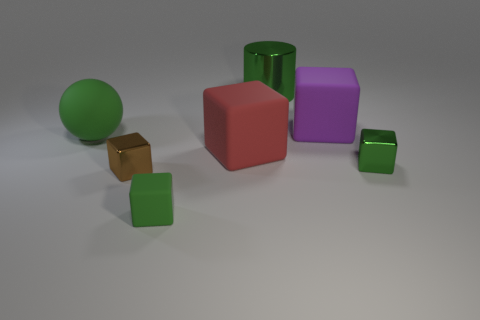What is the material of the brown object that is the same size as the green metal cube?
Your answer should be very brief. Metal. What number of other objects are the same material as the red cube?
Your answer should be very brief. 3. Do the red cube and the green block on the left side of the large purple object have the same size?
Give a very brief answer. No. Is the number of tiny cubes behind the brown thing less than the number of green objects that are in front of the green ball?
Offer a very short reply. Yes. There is a green metal object that is behind the purple matte cube; how big is it?
Ensure brevity in your answer.  Large. Do the brown cube and the red cube have the same size?
Give a very brief answer. No. How many cubes are in front of the large rubber sphere and on the right side of the green shiny cylinder?
Your answer should be very brief. 1. How many brown objects are either small blocks or tiny metallic things?
Give a very brief answer. 1. What number of metallic things are tiny cyan cylinders or tiny cubes?
Ensure brevity in your answer.  2. Is there a blue metal cube?
Your answer should be compact. No. 